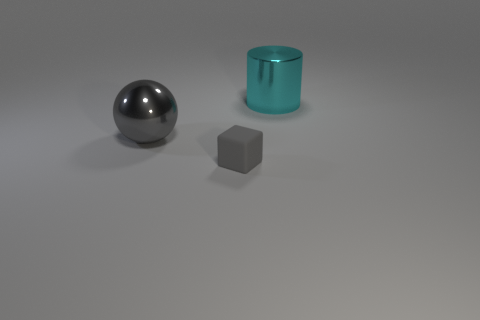Is there anything else that has the same shape as the gray rubber thing?
Give a very brief answer. No. What number of balls are tiny rubber things or gray metallic things?
Offer a terse response. 1. What is the color of the object that is in front of the big metal ball?
Your answer should be compact. Gray. The gray thing that is the same size as the cyan cylinder is what shape?
Make the answer very short. Sphere. There is a cube; how many gray metallic spheres are to the left of it?
Provide a short and direct response. 1. What number of things are either small purple objects or rubber blocks?
Offer a very short reply. 1. There is a thing that is both behind the tiny gray thing and in front of the big cyan shiny cylinder; what is its shape?
Provide a short and direct response. Sphere. What number of green rubber cubes are there?
Give a very brief answer. 0. The cylinder that is made of the same material as the large sphere is what color?
Your response must be concise. Cyan. Is the number of large cylinders greater than the number of brown metallic things?
Ensure brevity in your answer.  Yes. 